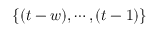<formula> <loc_0><loc_0><loc_500><loc_500>\{ ( t - w ) , \cdots , ( t - 1 ) \}</formula> 